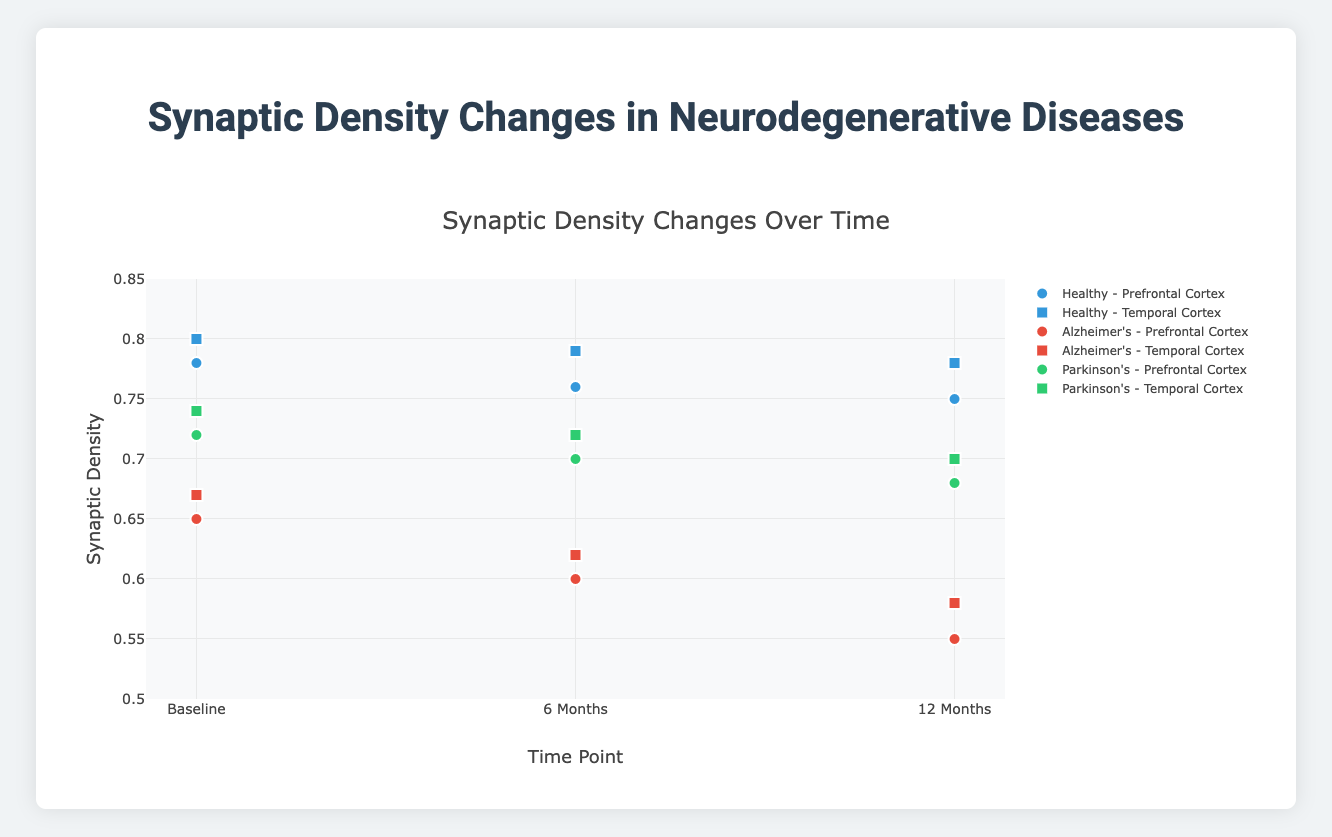What is the title of the plot? The title of the plot is displayed prominently at the top. It reads "Synaptic Density Changes Over Time".
Answer: Synaptic Density Changes Over Time Which cortical area shows higher synaptic density for Parkinson's disease at 12 months, Prefrontal Cortex or Temporal Cortex? Compare the synaptic density at the 12-month time point for Parkinson's disease. For the Prefrontal Cortex, it's 0.68, and for Temporal Cortex, it's 0.70. Therefore, Temporal Cortex has a higher synaptic density.
Answer: Temporal Cortex How does the synaptic density in the Prefrontal Cortex for Alzheimer's disease change from Baseline to 12 Months? Look at the values for synaptic density in the Prefrontal Cortex for Alzheimer's disease over the time points. It decreases from 0.65 at Baseline to 0.55 at 12 Months. This shows a decline.
Answer: Decrease What is the average synaptic density for Healthy individuals in the Temporal Cortex across all time points? Identify the synaptic density values for Healthy individuals in the Temporal Cortex, which are 0.80, 0.79, and 0.78. Calculate the average: (0.80 + 0.79 + 0.78) / 3 = 0.79.
Answer: 0.79 Which disease status shows the most significant decrease in synaptic density in the Prefrontal Cortex from Baseline to 12 Months? Compare the synaptic density decrease for each disease status in the Prefrontal Cortex. Alzheimer's declines from 0.65 to 0.55 (0.10), Parkinson's declines from 0.72 to 0.68 (0.04), and Healthy declines from 0.78 to 0.75 (0.03). Alzheimer's shows the most significant decrease.
Answer: Alzheimer's What is the difference in synaptic density between Healthy and Alzheimer's individuals in the Temporal Cortex at the 6-Month time point? At 6 Months, Healthy individuals have a synaptic density of 0.79, and Alzheimer's individuals have 0.62. The difference is 0.79 - 0.62 = 0.17.
Answer: 0.17 Which time point generally shows the lowest synaptic density across all groups and cortical areas? Compare the synaptic densities across all groups and areas at each time point. Notice that the 12-Month time point generally displays the lowest values compared to Baseline and 6 Months.
Answer: 12 Months How does the synaptic density of Healthy individuals in the Prefrontal Cortex compare to those with Parkinson's in the same region over all time points? Compare the values for both groups in the Prefrontal Cortex over time. Healthy: 0.78, 0.76, 0.75; Parkinson's: 0.72, 0.70, 0.68. Healthy individuals consistently show higher synaptic density at each time point.
Answer: Higher Is the synaptic density in the Temporal Cortex at 6 Months higher for Healthy or Parkinson's individuals? Compare the synaptic densities at 6 Months for both groups in the Temporal Cortex. Healthy individuals have 0.79, while Parkinson's have 0.72. Healthy individuals show higher synaptic density.
Answer: Healthy What pattern do you observe in synaptic density changes over time for individuals with Alzheimer's in the Temporal Cortex? Evaluate the synaptic density at Baseline (0.67), 6 Months (0.62), and 12 Months (0.58) for Alzheimer’s individuals. It continuously decreases over time.
Answer: Continuous decrease 